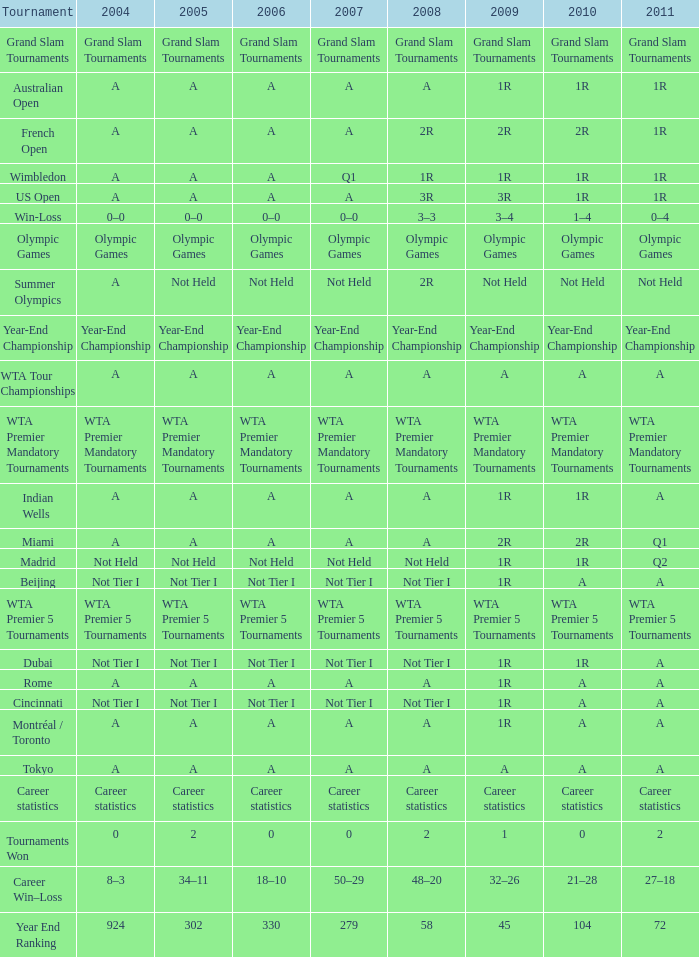What is 2007, when Tournament is "Madrid"? Not Held. 